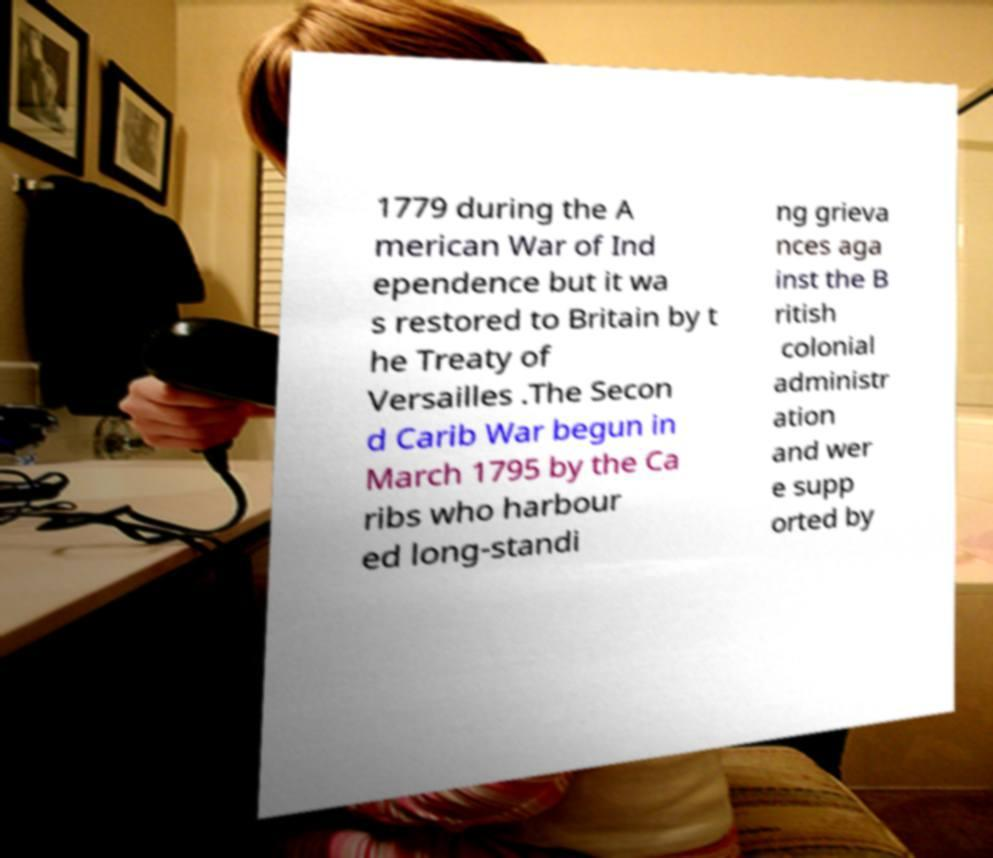Please identify and transcribe the text found in this image. 1779 during the A merican War of Ind ependence but it wa s restored to Britain by t he Treaty of Versailles .The Secon d Carib War begun in March 1795 by the Ca ribs who harbour ed long-standi ng grieva nces aga inst the B ritish colonial administr ation and wer e supp orted by 